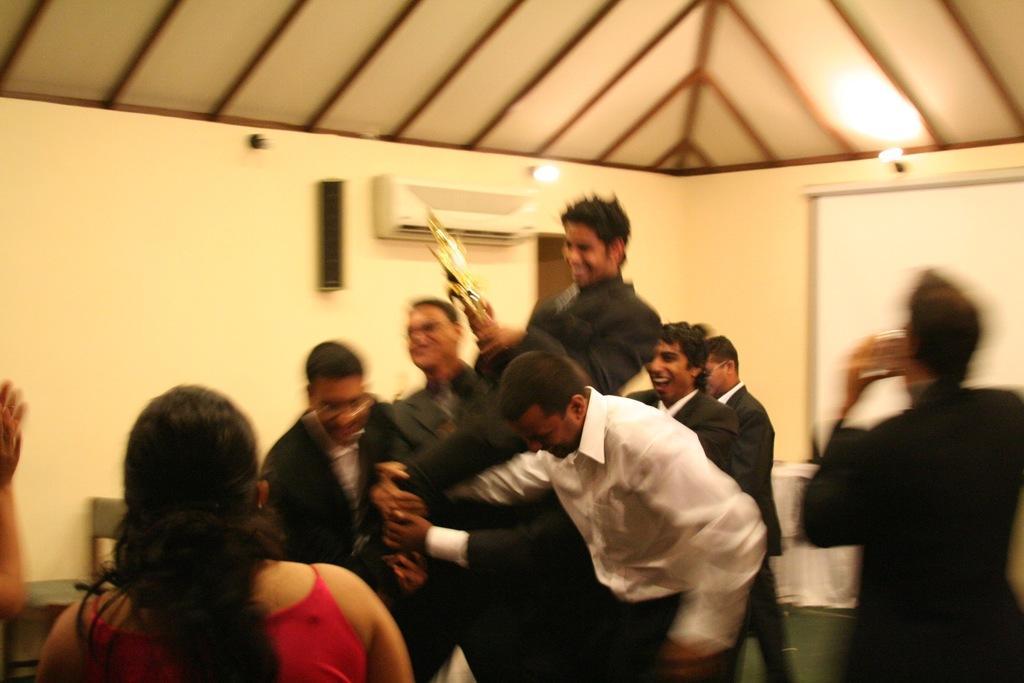Can you describe this image briefly? In this image we can see some group of persons standing and persons lifting up a person who is wearing black color dress, also holding some award in his hands and in the background of the image there is a projector screen, AC, sound box and there are some lights. 